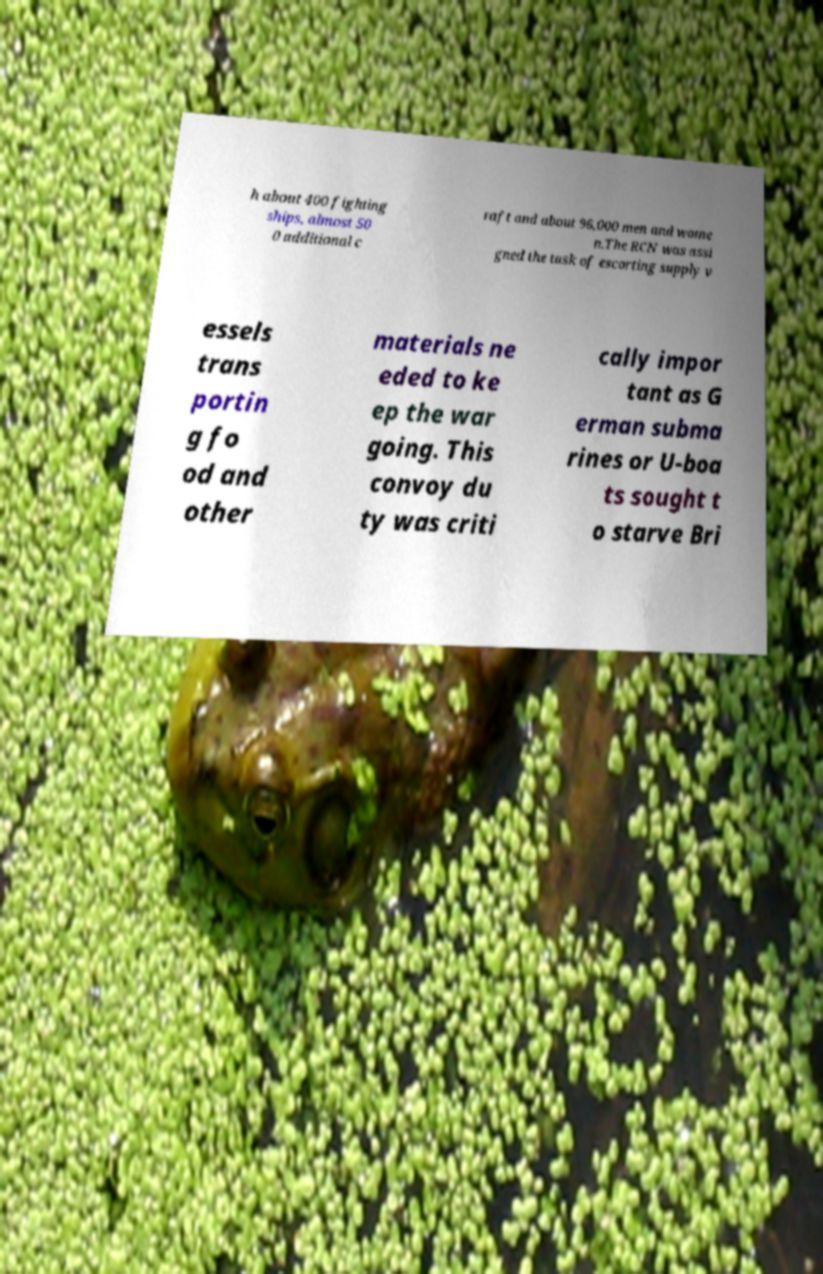Could you assist in decoding the text presented in this image and type it out clearly? h about 400 fighting ships, almost 50 0 additional c raft and about 96,000 men and wome n.The RCN was assi gned the task of escorting supply v essels trans portin g fo od and other materials ne eded to ke ep the war going. This convoy du ty was criti cally impor tant as G erman subma rines or U-boa ts sought t o starve Bri 